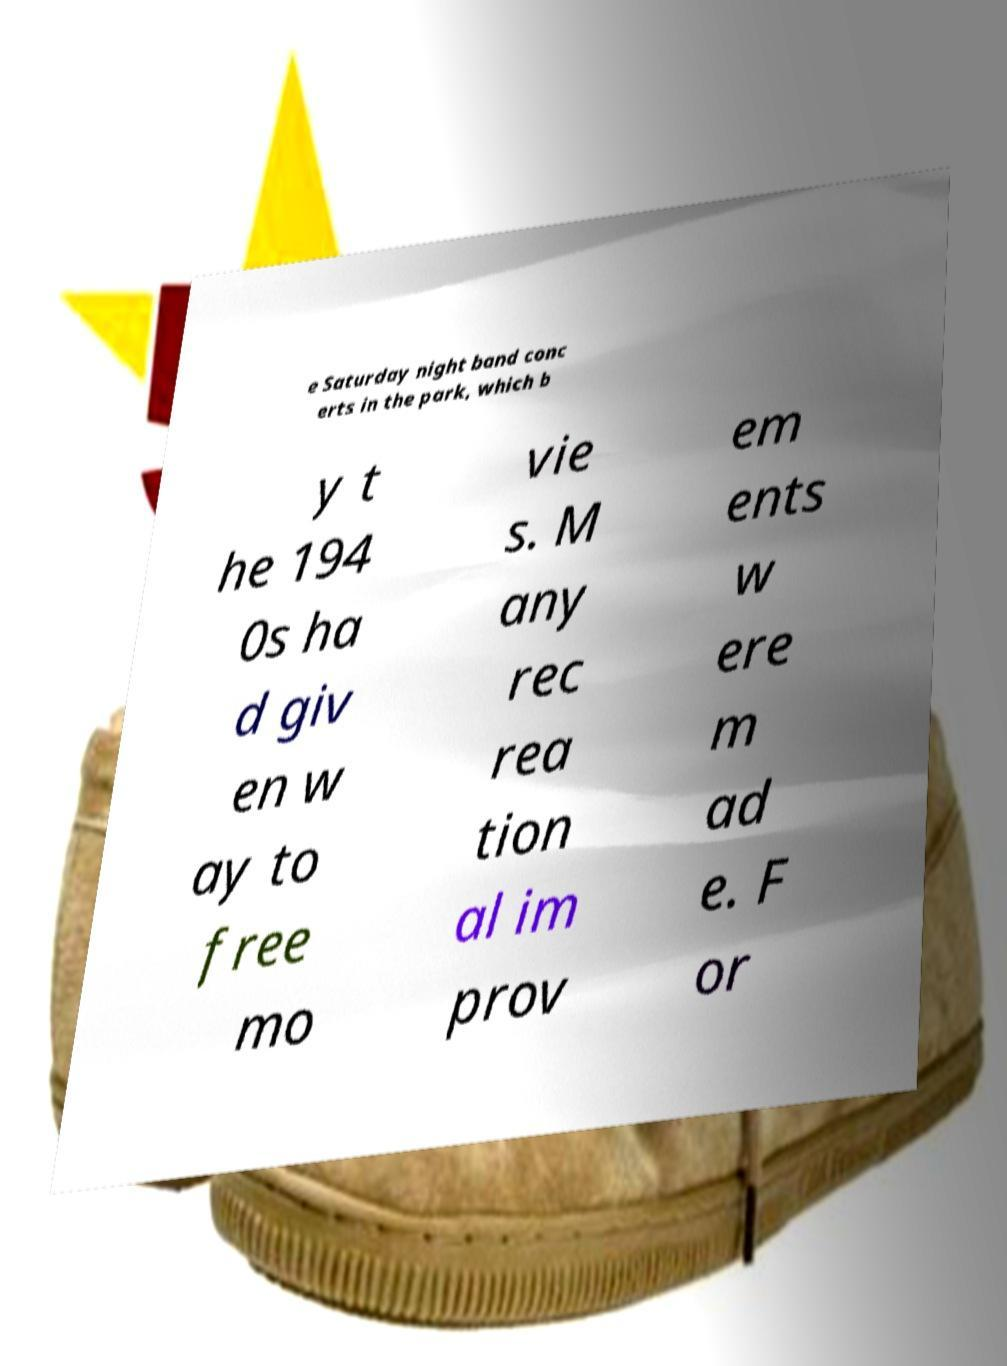I need the written content from this picture converted into text. Can you do that? e Saturday night band conc erts in the park, which b y t he 194 0s ha d giv en w ay to free mo vie s. M any rec rea tion al im prov em ents w ere m ad e. F or 